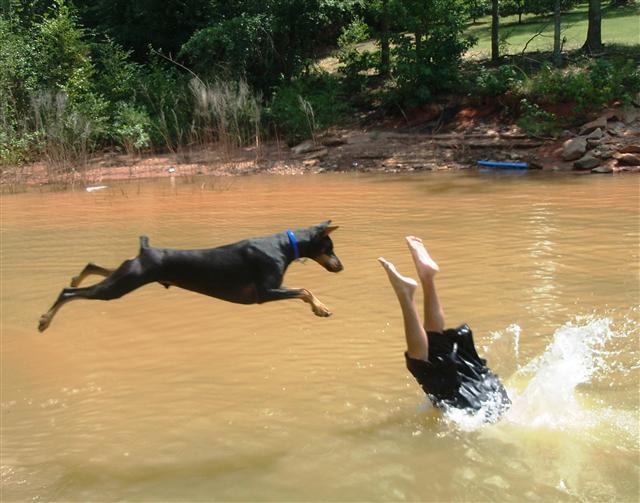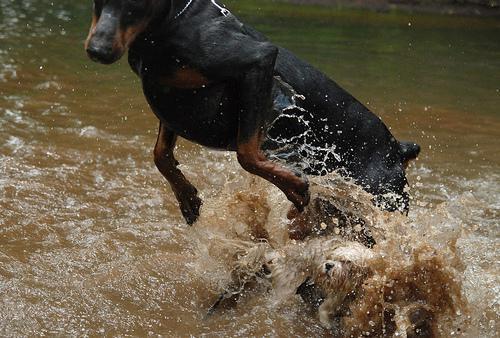The first image is the image on the left, the second image is the image on the right. Evaluate the accuracy of this statement regarding the images: "The right image shows a left-facing doberman creating a splash, with its front paws off the ground.". Is it true? Answer yes or no. Yes. The first image is the image on the left, the second image is the image on the right. Considering the images on both sides, is "Three or more mammals are visible." valid? Answer yes or no. Yes. 